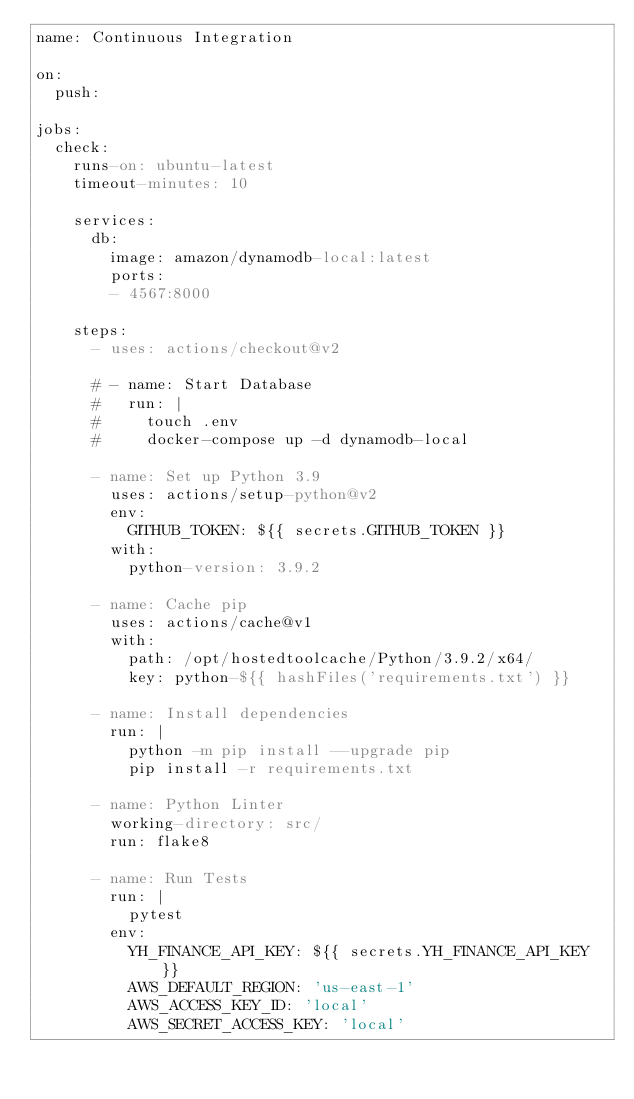Convert code to text. <code><loc_0><loc_0><loc_500><loc_500><_YAML_>name: Continuous Integration

on:
  push:

jobs:
  check:
    runs-on: ubuntu-latest
    timeout-minutes: 10

    services:
      db:
        image: amazon/dynamodb-local:latest
        ports:
        - 4567:8000

    steps:
      - uses: actions/checkout@v2

      # - name: Start Database
      #   run: |
      #     touch .env
      #     docker-compose up -d dynamodb-local

      - name: Set up Python 3.9
        uses: actions/setup-python@v2
        env:
          GITHUB_TOKEN: ${{ secrets.GITHUB_TOKEN }}
        with:
          python-version: 3.9.2

      - name: Cache pip
        uses: actions/cache@v1
        with:
          path: /opt/hostedtoolcache/Python/3.9.2/x64/
          key: python-${{ hashFiles('requirements.txt') }}

      - name: Install dependencies
        run: |
          python -m pip install --upgrade pip
          pip install -r requirements.txt

      - name: Python Linter
        working-directory: src/
        run: flake8

      - name: Run Tests
        run: |
          pytest
        env:
          YH_FINANCE_API_KEY: ${{ secrets.YH_FINANCE_API_KEY }}
          AWS_DEFAULT_REGION: 'us-east-1'
          AWS_ACCESS_KEY_ID: 'local'
          AWS_SECRET_ACCESS_KEY: 'local'</code> 